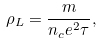<formula> <loc_0><loc_0><loc_500><loc_500>\rho _ { L } = \frac { m } { n _ { c } e ^ { 2 } \tau } ,</formula> 